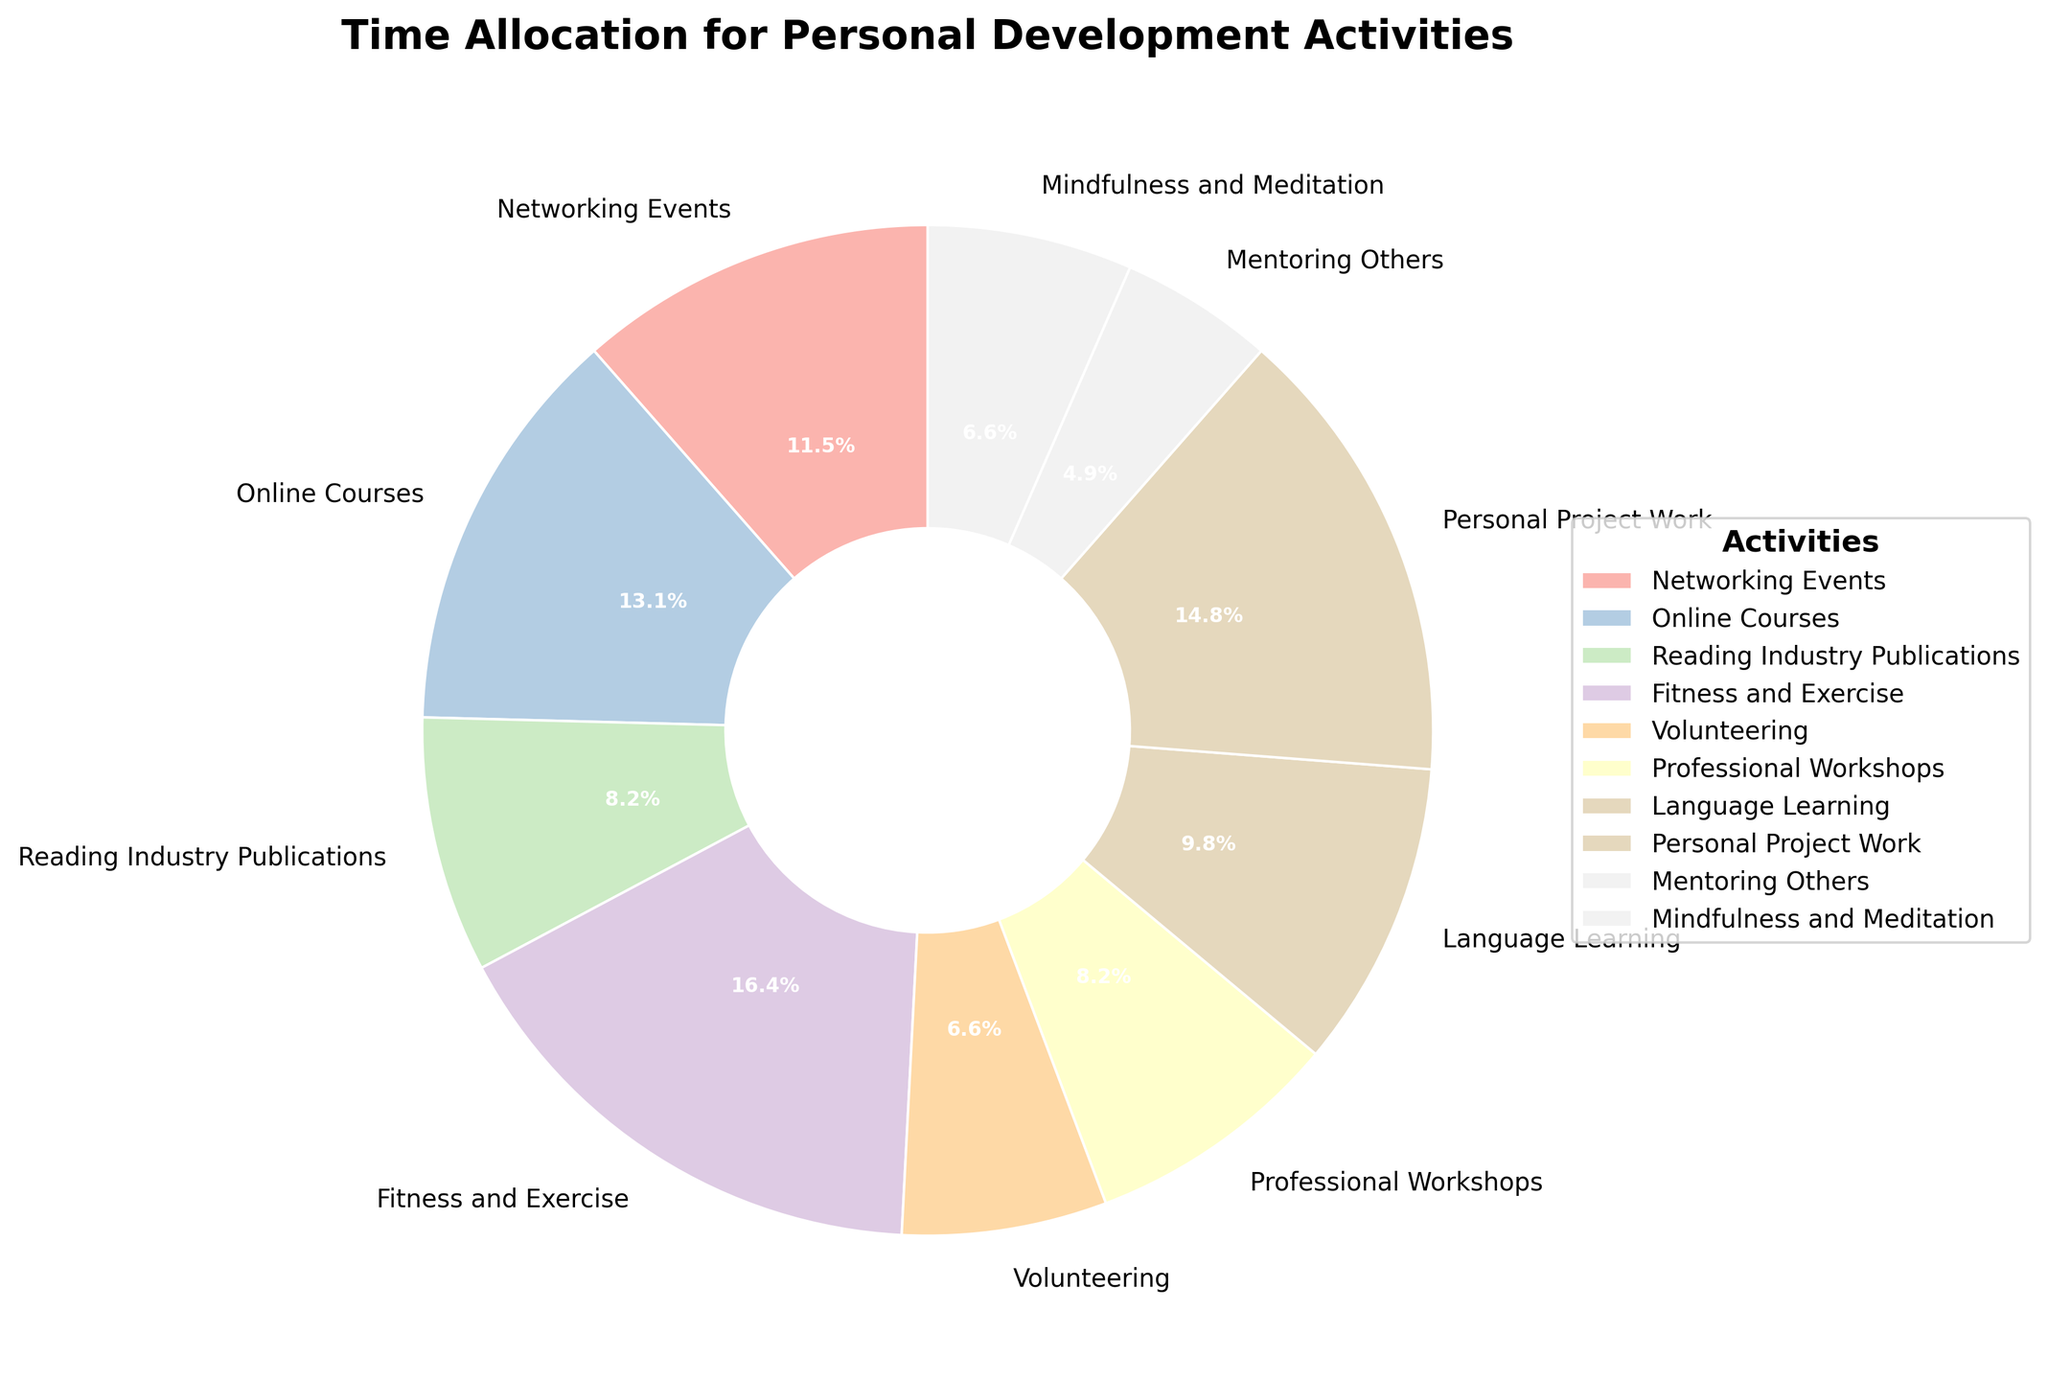Which activity has the highest percentage of time allocated? By looking at the pie chart, the largest wedge represents the activity with the highest percentage of time allocated.
Answer: Fitness and Exercise Which two activities together account for over 40% of the total time? First, find the activities with the highest percentages. Fitness and Exercise accounts for 19.3%, and Personal Project Work accounts for 17.4%. Adding these two gives 36.7%. Including Online Courses (15.5%), the combined total exceeds 40%.
Answer: Fitness and Exercise and Online Courses What is the combined percentage of time spent on Volunteering and Mentoring Others? From the chart, Volunteering accounts for 7.7%, and Mentoring Others accounts for 5.8%. Summing them up, we get 7.7% + 5.8% = 13.5%.
Answer: 13.5% Which activity has a larger percentage of time allocated: Reading Industry Publications or Professional Workshops? By comparing the wedges for Reading Industry Publications and Professional Workshops, we see that both have the same percentage of 9.6%.
Answer: They are equal Are there more hours allocated to Fitness and Exercise or to Personal Project Work? Comparing the pie chart wedges, Fitness and Exercise has 5 hours per week, while Personal Project Work has 4.5 hours per week. 5 is greater than 4.5.
Answer: Fitness and Exercise If we combine the time allocated to Networking Events, Language Learning, and Mindfulness and Meditation, what is the total percentage? From the chart, Networking Events is 13.5%, Language Learning is 11.6%, and Mindfulness and Meditation is 7.7%. Adding these gives 13.5% + 11.6% + 7.7% = 32.8%.
Answer: 32.8% What's the difference in time allocation between the most and least allocated activities? The most allocated activity is Fitness and Exercise with 5 hours per week, and the least allocated activity is Mentoring Others with 1.5 hours per week. The difference is 5 - 1.5 = 3.5 hours per week.
Answer: 3.5 hours per week Which activities use colors closer in the color spectrum? Fitness and Exercise and Reading Industry Publications are depicted in colors closer in the color spectrum as per the color-coding scheme in the chart.
Answer: Fitness and Exercise and Reading Industry Publications What percentage of time is spent on fitness-related activities? Fitness and Exercise is directly stated as 19.3% on the chart.
Answer: 19.3% Which activity, between Online Courses and Language Learning, takes up more time weekly? Online Courses take up 4 hours per week, while Language Learning takes up 3 hours per week. 4 is greater than 3.
Answer: Online Courses 